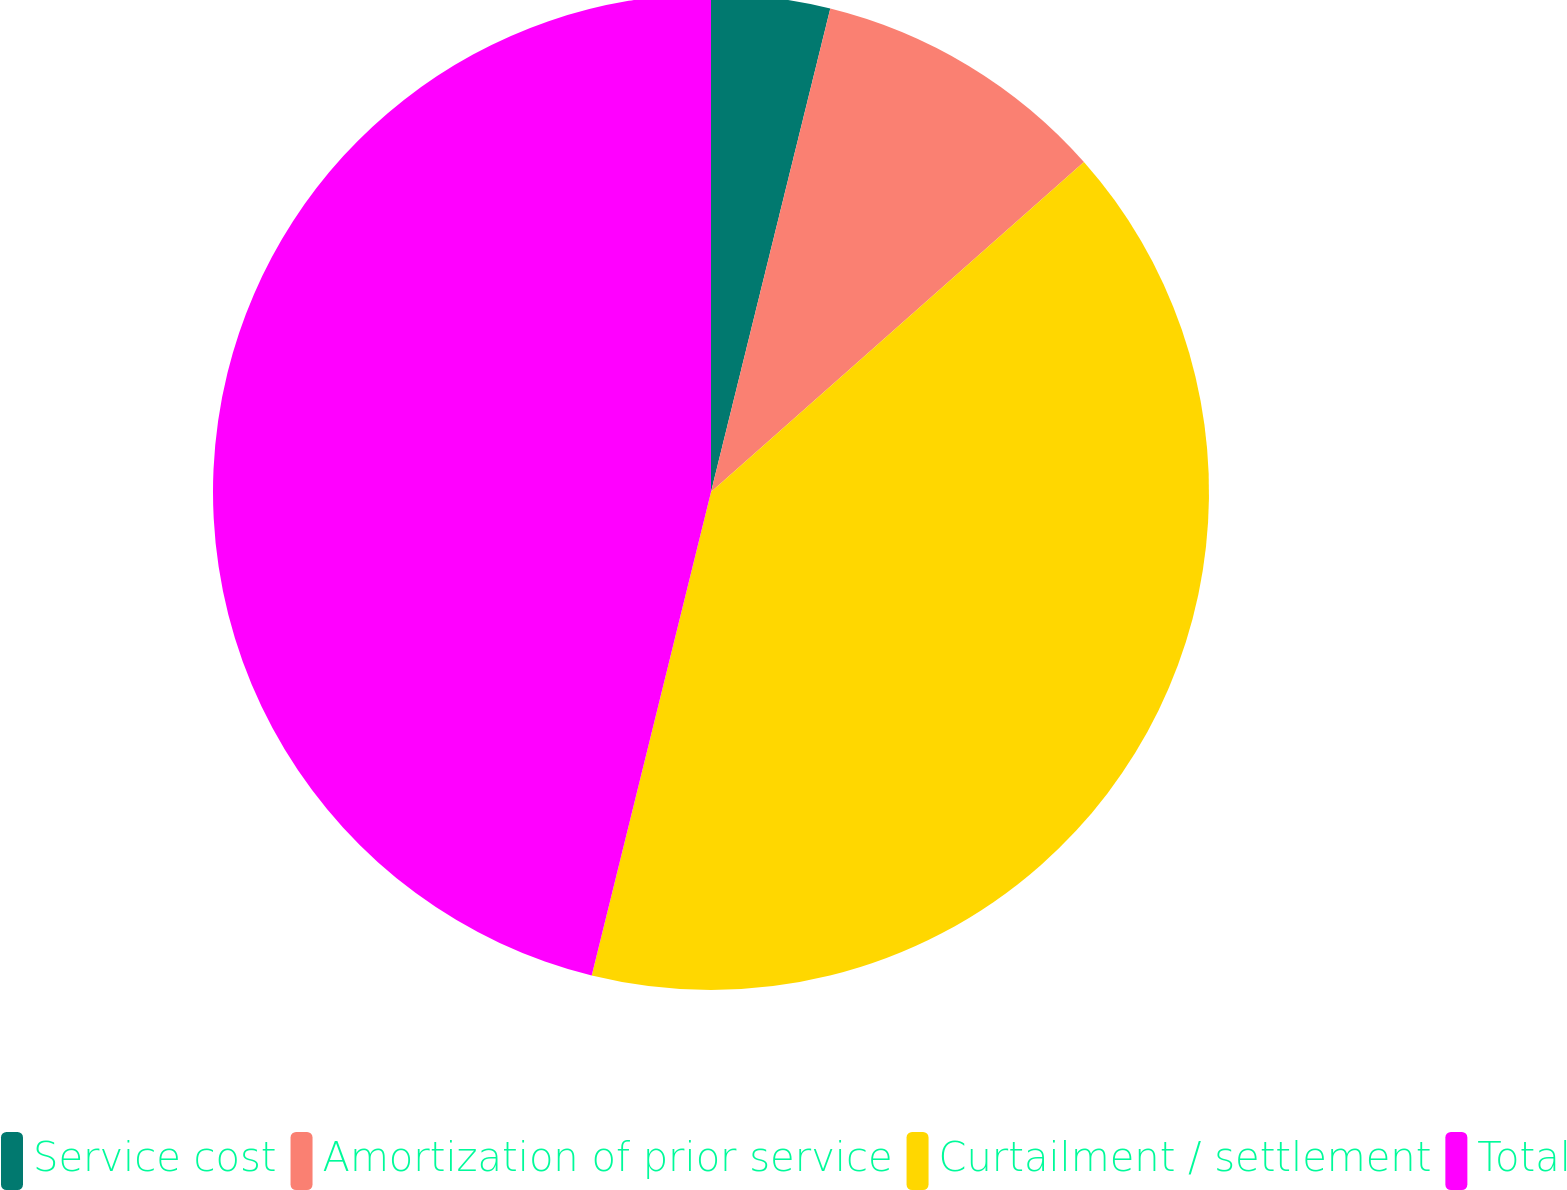Convert chart. <chart><loc_0><loc_0><loc_500><loc_500><pie_chart><fcel>Service cost<fcel>Amortization of prior service<fcel>Curtailment / settlement<fcel>Total<nl><fcel>3.85%<fcel>9.62%<fcel>40.38%<fcel>46.15%<nl></chart> 